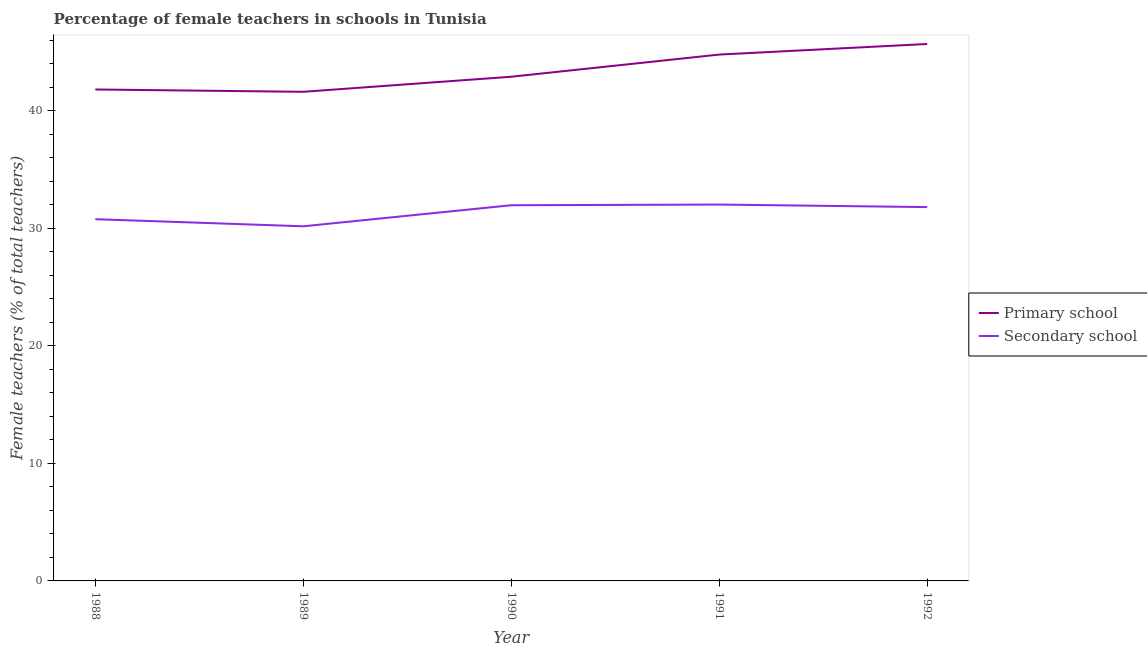How many different coloured lines are there?
Give a very brief answer. 2. Is the number of lines equal to the number of legend labels?
Make the answer very short. Yes. What is the percentage of female teachers in secondary schools in 1988?
Keep it short and to the point. 30.77. Across all years, what is the maximum percentage of female teachers in secondary schools?
Your answer should be very brief. 32.01. Across all years, what is the minimum percentage of female teachers in primary schools?
Your answer should be compact. 41.61. In which year was the percentage of female teachers in primary schools minimum?
Give a very brief answer. 1989. What is the total percentage of female teachers in primary schools in the graph?
Ensure brevity in your answer.  216.74. What is the difference between the percentage of female teachers in primary schools in 1990 and that in 1991?
Your response must be concise. -1.89. What is the difference between the percentage of female teachers in secondary schools in 1992 and the percentage of female teachers in primary schools in 1988?
Your response must be concise. -10. What is the average percentage of female teachers in primary schools per year?
Keep it short and to the point. 43.35. In the year 1988, what is the difference between the percentage of female teachers in primary schools and percentage of female teachers in secondary schools?
Keep it short and to the point. 11.03. What is the ratio of the percentage of female teachers in secondary schools in 1989 to that in 1992?
Offer a terse response. 0.95. Is the percentage of female teachers in primary schools in 1990 less than that in 1991?
Your answer should be compact. Yes. Is the difference between the percentage of female teachers in primary schools in 1990 and 1992 greater than the difference between the percentage of female teachers in secondary schools in 1990 and 1992?
Make the answer very short. No. What is the difference between the highest and the second highest percentage of female teachers in secondary schools?
Offer a terse response. 0.06. What is the difference between the highest and the lowest percentage of female teachers in secondary schools?
Make the answer very short. 1.85. Does the percentage of female teachers in primary schools monotonically increase over the years?
Provide a succinct answer. No. How many years are there in the graph?
Make the answer very short. 5. Are the values on the major ticks of Y-axis written in scientific E-notation?
Ensure brevity in your answer.  No. Where does the legend appear in the graph?
Provide a succinct answer. Center right. How many legend labels are there?
Your answer should be very brief. 2. What is the title of the graph?
Give a very brief answer. Percentage of female teachers in schools in Tunisia. Does "Register a business" appear as one of the legend labels in the graph?
Keep it short and to the point. No. What is the label or title of the Y-axis?
Give a very brief answer. Female teachers (% of total teachers). What is the Female teachers (% of total teachers) of Primary school in 1988?
Make the answer very short. 41.8. What is the Female teachers (% of total teachers) of Secondary school in 1988?
Your response must be concise. 30.77. What is the Female teachers (% of total teachers) of Primary school in 1989?
Your answer should be compact. 41.61. What is the Female teachers (% of total teachers) in Secondary school in 1989?
Your answer should be very brief. 30.16. What is the Female teachers (% of total teachers) of Primary school in 1990?
Provide a short and direct response. 42.89. What is the Female teachers (% of total teachers) in Secondary school in 1990?
Make the answer very short. 31.96. What is the Female teachers (% of total teachers) of Primary school in 1991?
Your answer should be very brief. 44.77. What is the Female teachers (% of total teachers) of Secondary school in 1991?
Give a very brief answer. 32.01. What is the Female teachers (% of total teachers) of Primary school in 1992?
Your answer should be compact. 45.67. What is the Female teachers (% of total teachers) in Secondary school in 1992?
Keep it short and to the point. 31.8. Across all years, what is the maximum Female teachers (% of total teachers) of Primary school?
Offer a very short reply. 45.67. Across all years, what is the maximum Female teachers (% of total teachers) of Secondary school?
Make the answer very short. 32.01. Across all years, what is the minimum Female teachers (% of total teachers) of Primary school?
Offer a terse response. 41.61. Across all years, what is the minimum Female teachers (% of total teachers) of Secondary school?
Offer a very short reply. 30.16. What is the total Female teachers (% of total teachers) in Primary school in the graph?
Make the answer very short. 216.74. What is the total Female teachers (% of total teachers) of Secondary school in the graph?
Offer a terse response. 156.7. What is the difference between the Female teachers (% of total teachers) of Primary school in 1988 and that in 1989?
Give a very brief answer. 0.2. What is the difference between the Female teachers (% of total teachers) of Secondary school in 1988 and that in 1989?
Provide a short and direct response. 0.6. What is the difference between the Female teachers (% of total teachers) of Primary school in 1988 and that in 1990?
Provide a short and direct response. -1.08. What is the difference between the Female teachers (% of total teachers) of Secondary school in 1988 and that in 1990?
Make the answer very short. -1.19. What is the difference between the Female teachers (% of total teachers) in Primary school in 1988 and that in 1991?
Your answer should be very brief. -2.97. What is the difference between the Female teachers (% of total teachers) of Secondary school in 1988 and that in 1991?
Provide a succinct answer. -1.24. What is the difference between the Female teachers (% of total teachers) in Primary school in 1988 and that in 1992?
Keep it short and to the point. -3.87. What is the difference between the Female teachers (% of total teachers) in Secondary school in 1988 and that in 1992?
Offer a terse response. -1.03. What is the difference between the Female teachers (% of total teachers) of Primary school in 1989 and that in 1990?
Your answer should be compact. -1.28. What is the difference between the Female teachers (% of total teachers) of Secondary school in 1989 and that in 1990?
Your response must be concise. -1.79. What is the difference between the Female teachers (% of total teachers) of Primary school in 1989 and that in 1991?
Your answer should be compact. -3.17. What is the difference between the Female teachers (% of total teachers) in Secondary school in 1989 and that in 1991?
Give a very brief answer. -1.85. What is the difference between the Female teachers (% of total teachers) of Primary school in 1989 and that in 1992?
Keep it short and to the point. -4.07. What is the difference between the Female teachers (% of total teachers) of Secondary school in 1989 and that in 1992?
Make the answer very short. -1.63. What is the difference between the Female teachers (% of total teachers) of Primary school in 1990 and that in 1991?
Your answer should be very brief. -1.89. What is the difference between the Female teachers (% of total teachers) in Secondary school in 1990 and that in 1991?
Provide a short and direct response. -0.06. What is the difference between the Female teachers (% of total teachers) of Primary school in 1990 and that in 1992?
Your response must be concise. -2.79. What is the difference between the Female teachers (% of total teachers) of Secondary school in 1990 and that in 1992?
Your answer should be compact. 0.16. What is the difference between the Female teachers (% of total teachers) of Primary school in 1991 and that in 1992?
Offer a terse response. -0.9. What is the difference between the Female teachers (% of total teachers) of Secondary school in 1991 and that in 1992?
Ensure brevity in your answer.  0.21. What is the difference between the Female teachers (% of total teachers) of Primary school in 1988 and the Female teachers (% of total teachers) of Secondary school in 1989?
Offer a very short reply. 11.64. What is the difference between the Female teachers (% of total teachers) of Primary school in 1988 and the Female teachers (% of total teachers) of Secondary school in 1990?
Ensure brevity in your answer.  9.85. What is the difference between the Female teachers (% of total teachers) in Primary school in 1988 and the Female teachers (% of total teachers) in Secondary school in 1991?
Provide a succinct answer. 9.79. What is the difference between the Female teachers (% of total teachers) of Primary school in 1988 and the Female teachers (% of total teachers) of Secondary school in 1992?
Make the answer very short. 10. What is the difference between the Female teachers (% of total teachers) of Primary school in 1989 and the Female teachers (% of total teachers) of Secondary school in 1990?
Provide a short and direct response. 9.65. What is the difference between the Female teachers (% of total teachers) of Primary school in 1989 and the Female teachers (% of total teachers) of Secondary school in 1991?
Keep it short and to the point. 9.59. What is the difference between the Female teachers (% of total teachers) of Primary school in 1989 and the Female teachers (% of total teachers) of Secondary school in 1992?
Keep it short and to the point. 9.81. What is the difference between the Female teachers (% of total teachers) of Primary school in 1990 and the Female teachers (% of total teachers) of Secondary school in 1991?
Your answer should be very brief. 10.87. What is the difference between the Female teachers (% of total teachers) of Primary school in 1990 and the Female teachers (% of total teachers) of Secondary school in 1992?
Provide a succinct answer. 11.09. What is the difference between the Female teachers (% of total teachers) of Primary school in 1991 and the Female teachers (% of total teachers) of Secondary school in 1992?
Make the answer very short. 12.97. What is the average Female teachers (% of total teachers) in Primary school per year?
Your response must be concise. 43.35. What is the average Female teachers (% of total teachers) of Secondary school per year?
Offer a terse response. 31.34. In the year 1988, what is the difference between the Female teachers (% of total teachers) in Primary school and Female teachers (% of total teachers) in Secondary school?
Provide a short and direct response. 11.03. In the year 1989, what is the difference between the Female teachers (% of total teachers) in Primary school and Female teachers (% of total teachers) in Secondary school?
Provide a short and direct response. 11.44. In the year 1990, what is the difference between the Female teachers (% of total teachers) in Primary school and Female teachers (% of total teachers) in Secondary school?
Keep it short and to the point. 10.93. In the year 1991, what is the difference between the Female teachers (% of total teachers) in Primary school and Female teachers (% of total teachers) in Secondary school?
Make the answer very short. 12.76. In the year 1992, what is the difference between the Female teachers (% of total teachers) in Primary school and Female teachers (% of total teachers) in Secondary school?
Provide a succinct answer. 13.87. What is the ratio of the Female teachers (% of total teachers) in Secondary school in 1988 to that in 1989?
Make the answer very short. 1.02. What is the ratio of the Female teachers (% of total teachers) of Primary school in 1988 to that in 1990?
Your answer should be compact. 0.97. What is the ratio of the Female teachers (% of total teachers) of Secondary school in 1988 to that in 1990?
Offer a terse response. 0.96. What is the ratio of the Female teachers (% of total teachers) of Primary school in 1988 to that in 1991?
Keep it short and to the point. 0.93. What is the ratio of the Female teachers (% of total teachers) in Secondary school in 1988 to that in 1991?
Provide a succinct answer. 0.96. What is the ratio of the Female teachers (% of total teachers) in Primary school in 1988 to that in 1992?
Give a very brief answer. 0.92. What is the ratio of the Female teachers (% of total teachers) of Secondary school in 1988 to that in 1992?
Your response must be concise. 0.97. What is the ratio of the Female teachers (% of total teachers) of Primary school in 1989 to that in 1990?
Provide a short and direct response. 0.97. What is the ratio of the Female teachers (% of total teachers) of Secondary school in 1989 to that in 1990?
Provide a short and direct response. 0.94. What is the ratio of the Female teachers (% of total teachers) of Primary school in 1989 to that in 1991?
Make the answer very short. 0.93. What is the ratio of the Female teachers (% of total teachers) in Secondary school in 1989 to that in 1991?
Your response must be concise. 0.94. What is the ratio of the Female teachers (% of total teachers) in Primary school in 1989 to that in 1992?
Provide a succinct answer. 0.91. What is the ratio of the Female teachers (% of total teachers) of Secondary school in 1989 to that in 1992?
Make the answer very short. 0.95. What is the ratio of the Female teachers (% of total teachers) of Primary school in 1990 to that in 1991?
Offer a terse response. 0.96. What is the ratio of the Female teachers (% of total teachers) of Secondary school in 1990 to that in 1991?
Ensure brevity in your answer.  1. What is the ratio of the Female teachers (% of total teachers) of Primary school in 1990 to that in 1992?
Give a very brief answer. 0.94. What is the ratio of the Female teachers (% of total teachers) in Secondary school in 1990 to that in 1992?
Ensure brevity in your answer.  1. What is the ratio of the Female teachers (% of total teachers) of Primary school in 1991 to that in 1992?
Offer a very short reply. 0.98. What is the ratio of the Female teachers (% of total teachers) in Secondary school in 1991 to that in 1992?
Your response must be concise. 1.01. What is the difference between the highest and the second highest Female teachers (% of total teachers) of Primary school?
Offer a terse response. 0.9. What is the difference between the highest and the second highest Female teachers (% of total teachers) of Secondary school?
Your response must be concise. 0.06. What is the difference between the highest and the lowest Female teachers (% of total teachers) in Primary school?
Ensure brevity in your answer.  4.07. What is the difference between the highest and the lowest Female teachers (% of total teachers) in Secondary school?
Offer a terse response. 1.85. 